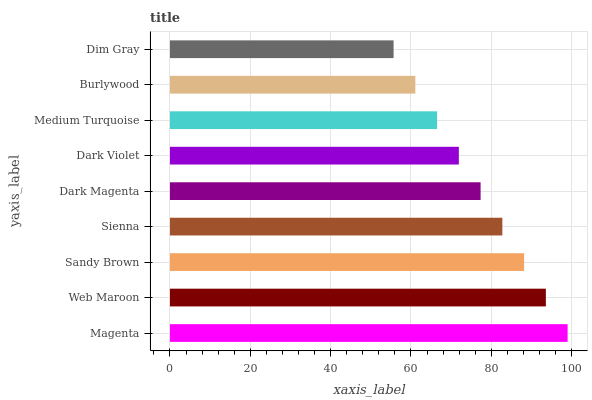Is Dim Gray the minimum?
Answer yes or no. Yes. Is Magenta the maximum?
Answer yes or no. Yes. Is Web Maroon the minimum?
Answer yes or no. No. Is Web Maroon the maximum?
Answer yes or no. No. Is Magenta greater than Web Maroon?
Answer yes or no. Yes. Is Web Maroon less than Magenta?
Answer yes or no. Yes. Is Web Maroon greater than Magenta?
Answer yes or no. No. Is Magenta less than Web Maroon?
Answer yes or no. No. Is Dark Magenta the high median?
Answer yes or no. Yes. Is Dark Magenta the low median?
Answer yes or no. Yes. Is Sienna the high median?
Answer yes or no. No. Is Dim Gray the low median?
Answer yes or no. No. 